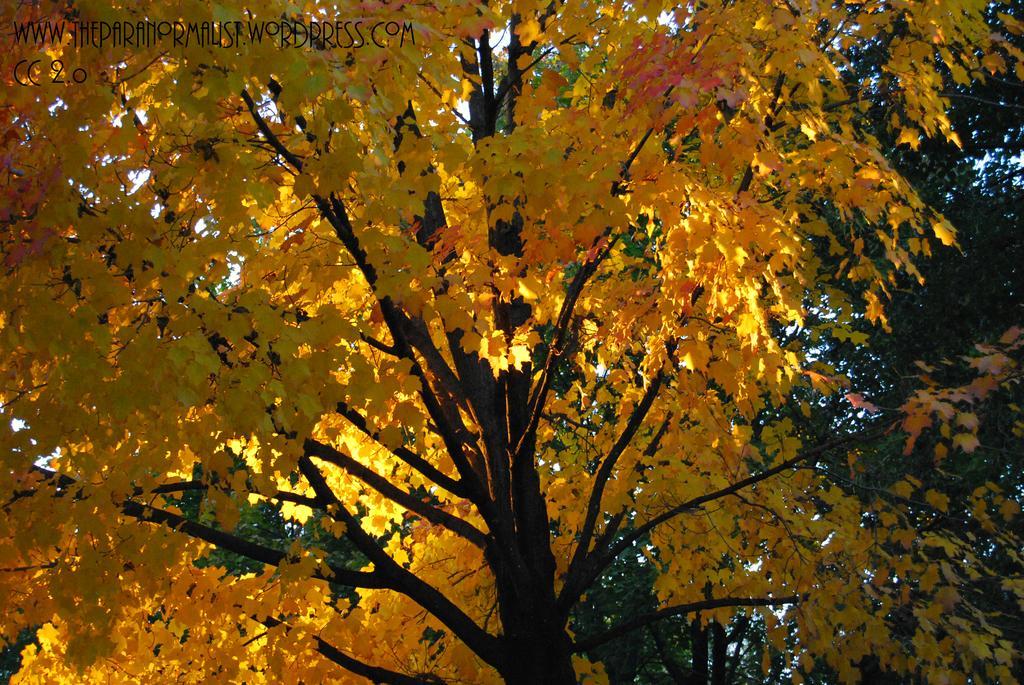Please provide a concise description of this image. In this picture I can see there is a tree and it has many branches and yellow leaves and into right there is a tree with green leaves and the sky is clear and there is something written at the top left of the image. 